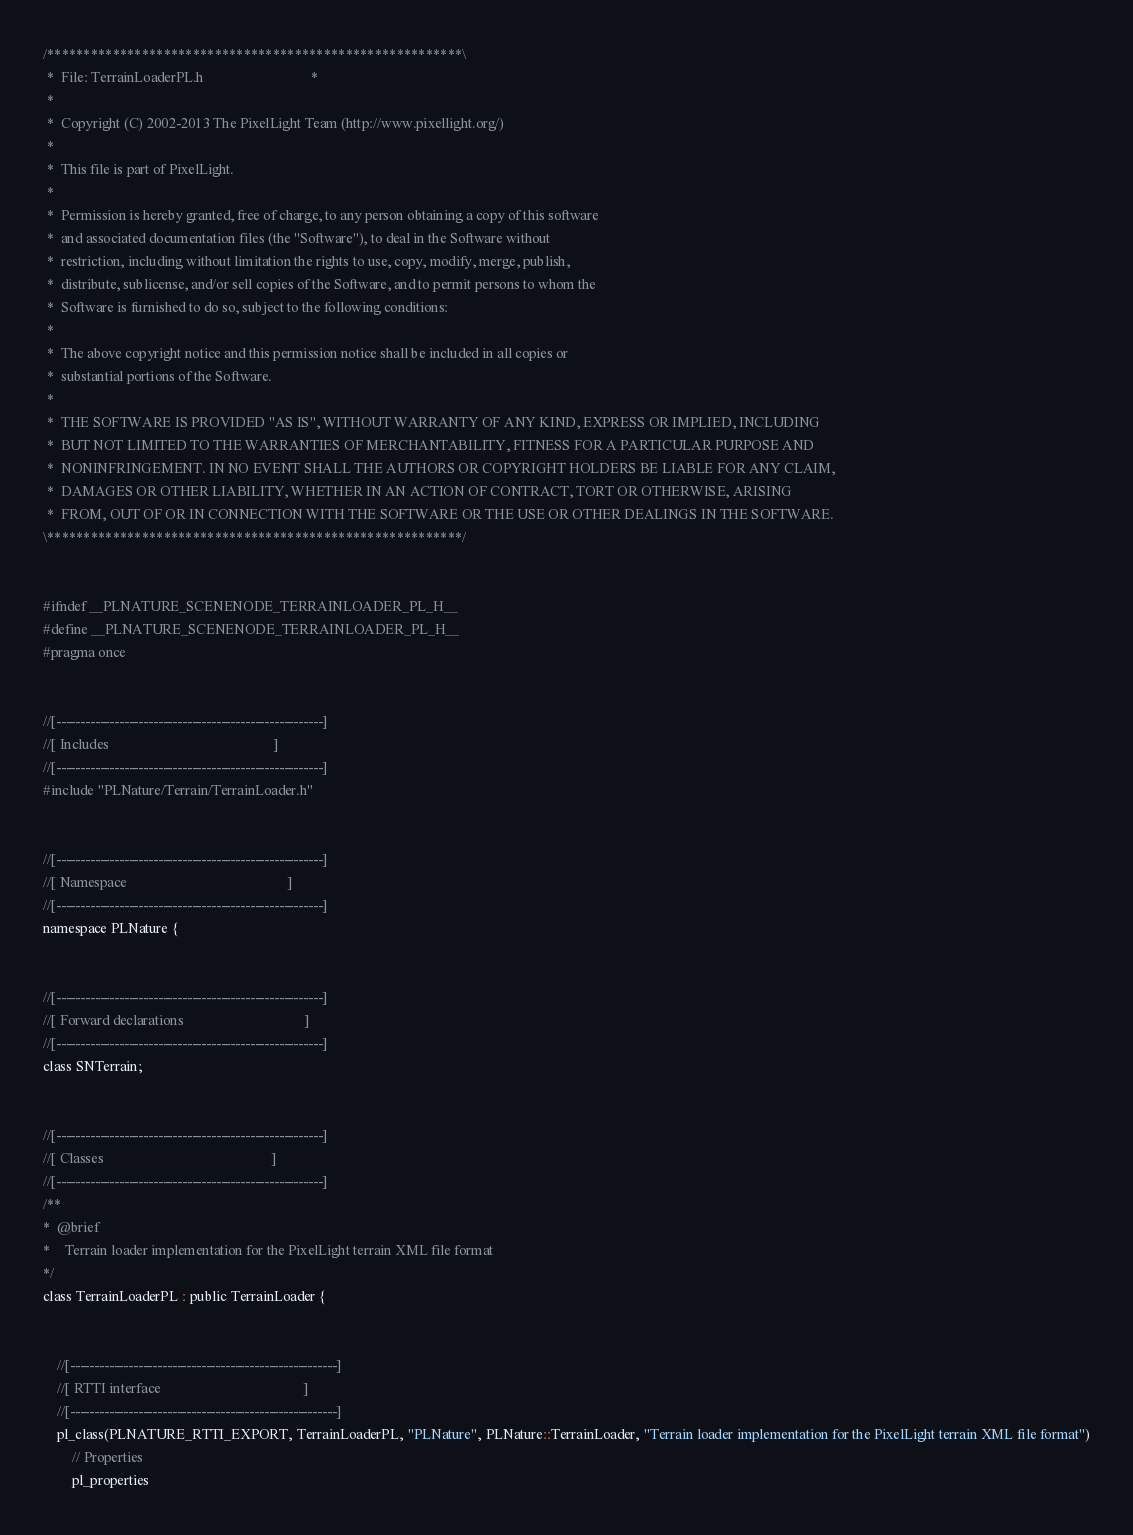Convert code to text. <code><loc_0><loc_0><loc_500><loc_500><_C_>/*********************************************************\
 *  File: TerrainLoaderPL.h                              *
 *
 *  Copyright (C) 2002-2013 The PixelLight Team (http://www.pixellight.org/)
 *
 *  This file is part of PixelLight.
 *
 *  Permission is hereby granted, free of charge, to any person obtaining a copy of this software
 *  and associated documentation files (the "Software"), to deal in the Software without
 *  restriction, including without limitation the rights to use, copy, modify, merge, publish,
 *  distribute, sublicense, and/or sell copies of the Software, and to permit persons to whom the
 *  Software is furnished to do so, subject to the following conditions:
 *
 *  The above copyright notice and this permission notice shall be included in all copies or
 *  substantial portions of the Software.
 *
 *  THE SOFTWARE IS PROVIDED "AS IS", WITHOUT WARRANTY OF ANY KIND, EXPRESS OR IMPLIED, INCLUDING
 *  BUT NOT LIMITED TO THE WARRANTIES OF MERCHANTABILITY, FITNESS FOR A PARTICULAR PURPOSE AND
 *  NONINFRINGEMENT. IN NO EVENT SHALL THE AUTHORS OR COPYRIGHT HOLDERS BE LIABLE FOR ANY CLAIM,
 *  DAMAGES OR OTHER LIABILITY, WHETHER IN AN ACTION OF CONTRACT, TORT OR OTHERWISE, ARISING
 *  FROM, OUT OF OR IN CONNECTION WITH THE SOFTWARE OR THE USE OR OTHER DEALINGS IN THE SOFTWARE.
\*********************************************************/


#ifndef __PLNATURE_SCENENODE_TERRAINLOADER_PL_H__
#define __PLNATURE_SCENENODE_TERRAINLOADER_PL_H__
#pragma once


//[-------------------------------------------------------]
//[ Includes                                              ]
//[-------------------------------------------------------]
#include "PLNature/Terrain/TerrainLoader.h"


//[-------------------------------------------------------]
//[ Namespace                                             ]
//[-------------------------------------------------------]
namespace PLNature {


//[-------------------------------------------------------]
//[ Forward declarations                                  ]
//[-------------------------------------------------------]
class SNTerrain;


//[-------------------------------------------------------]
//[ Classes                                               ]
//[-------------------------------------------------------]
/**
*  @brief
*    Terrain loader implementation for the PixelLight terrain XML file format
*/
class TerrainLoaderPL : public TerrainLoader {


	//[-------------------------------------------------------]
	//[ RTTI interface                                        ]
	//[-------------------------------------------------------]
	pl_class(PLNATURE_RTTI_EXPORT, TerrainLoaderPL, "PLNature", PLNature::TerrainLoader, "Terrain loader implementation for the PixelLight terrain XML file format")
		// Properties
		pl_properties</code> 